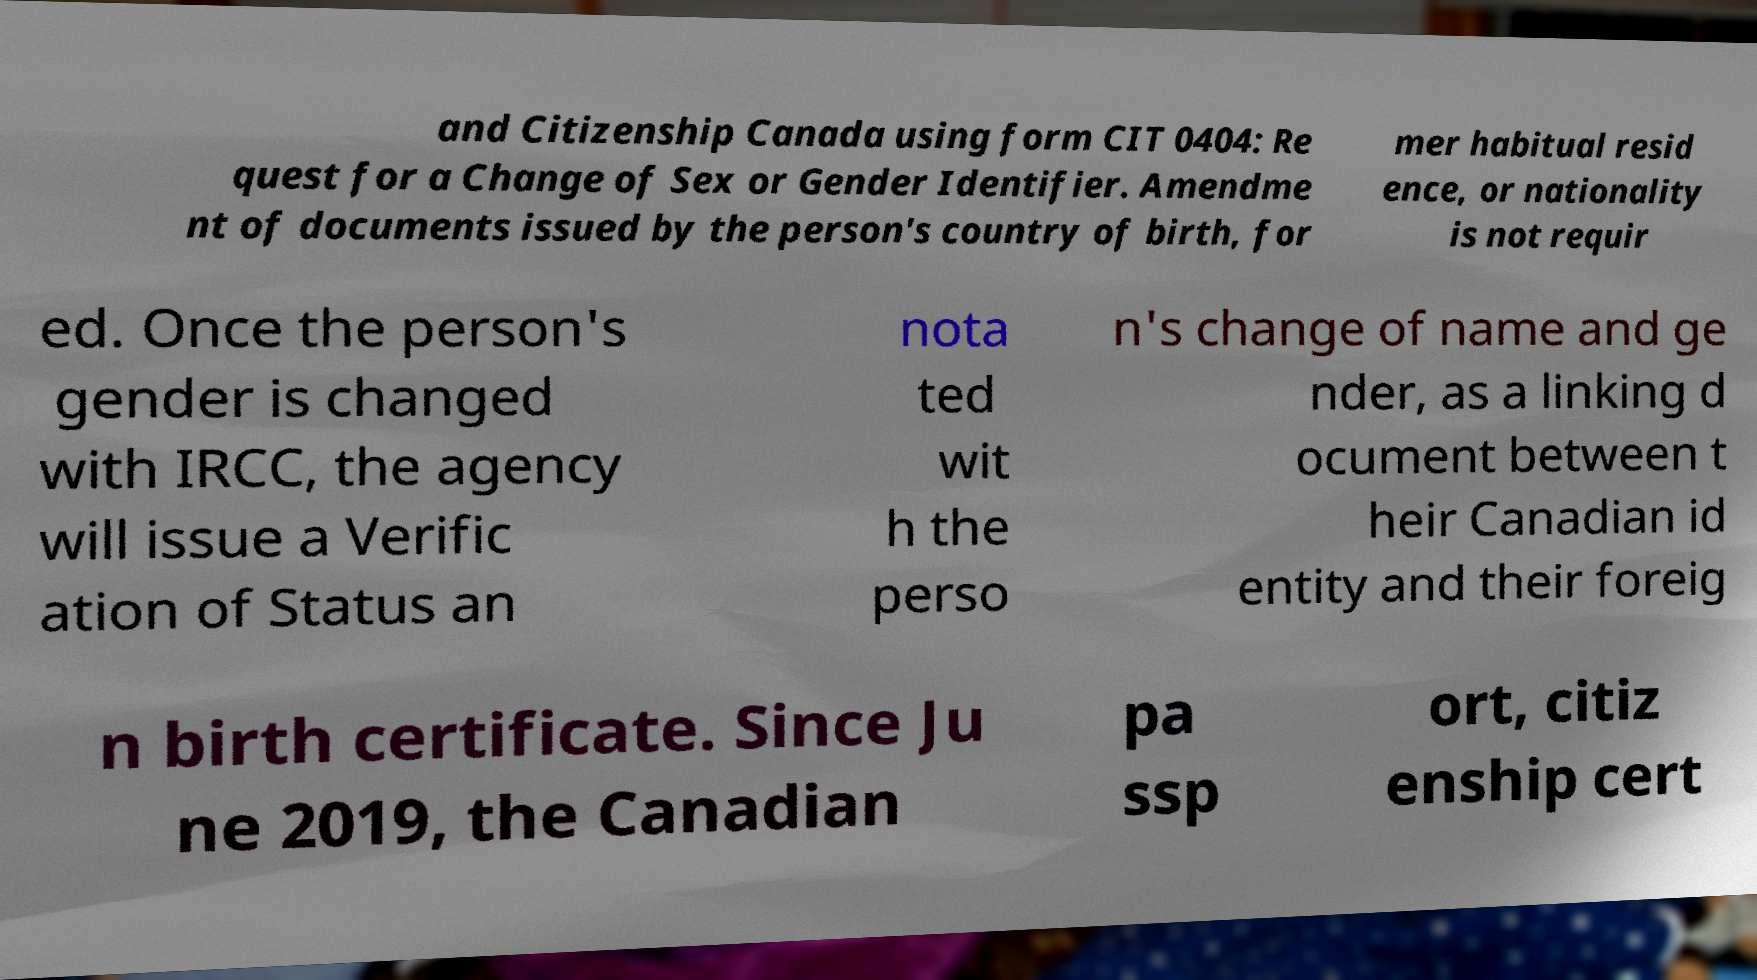Can you accurately transcribe the text from the provided image for me? and Citizenship Canada using form CIT 0404: Re quest for a Change of Sex or Gender Identifier. Amendme nt of documents issued by the person's country of birth, for mer habitual resid ence, or nationality is not requir ed. Once the person's gender is changed with IRCC, the agency will issue a Verific ation of Status an nota ted wit h the perso n's change of name and ge nder, as a linking d ocument between t heir Canadian id entity and their foreig n birth certificate. Since Ju ne 2019, the Canadian pa ssp ort, citiz enship cert 